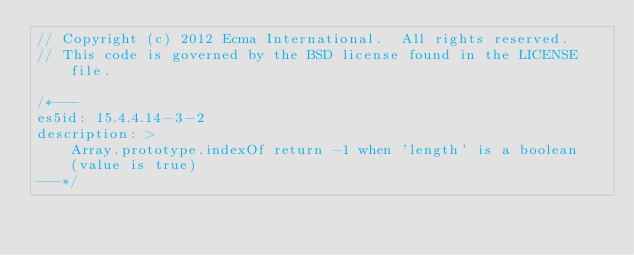<code> <loc_0><loc_0><loc_500><loc_500><_JavaScript_>// Copyright (c) 2012 Ecma International.  All rights reserved.
// This code is governed by the BSD license found in the LICENSE file.

/*---
es5id: 15.4.4.14-3-2
description: >
    Array.prototype.indexOf return -1 when 'length' is a boolean
    (value is true)
---*/
</code> 